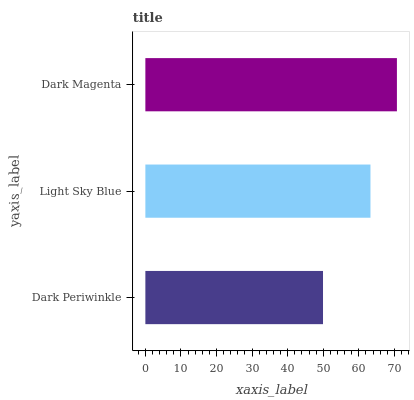Is Dark Periwinkle the minimum?
Answer yes or no. Yes. Is Dark Magenta the maximum?
Answer yes or no. Yes. Is Light Sky Blue the minimum?
Answer yes or no. No. Is Light Sky Blue the maximum?
Answer yes or no. No. Is Light Sky Blue greater than Dark Periwinkle?
Answer yes or no. Yes. Is Dark Periwinkle less than Light Sky Blue?
Answer yes or no. Yes. Is Dark Periwinkle greater than Light Sky Blue?
Answer yes or no. No. Is Light Sky Blue less than Dark Periwinkle?
Answer yes or no. No. Is Light Sky Blue the high median?
Answer yes or no. Yes. Is Light Sky Blue the low median?
Answer yes or no. Yes. Is Dark Periwinkle the high median?
Answer yes or no. No. Is Dark Magenta the low median?
Answer yes or no. No. 